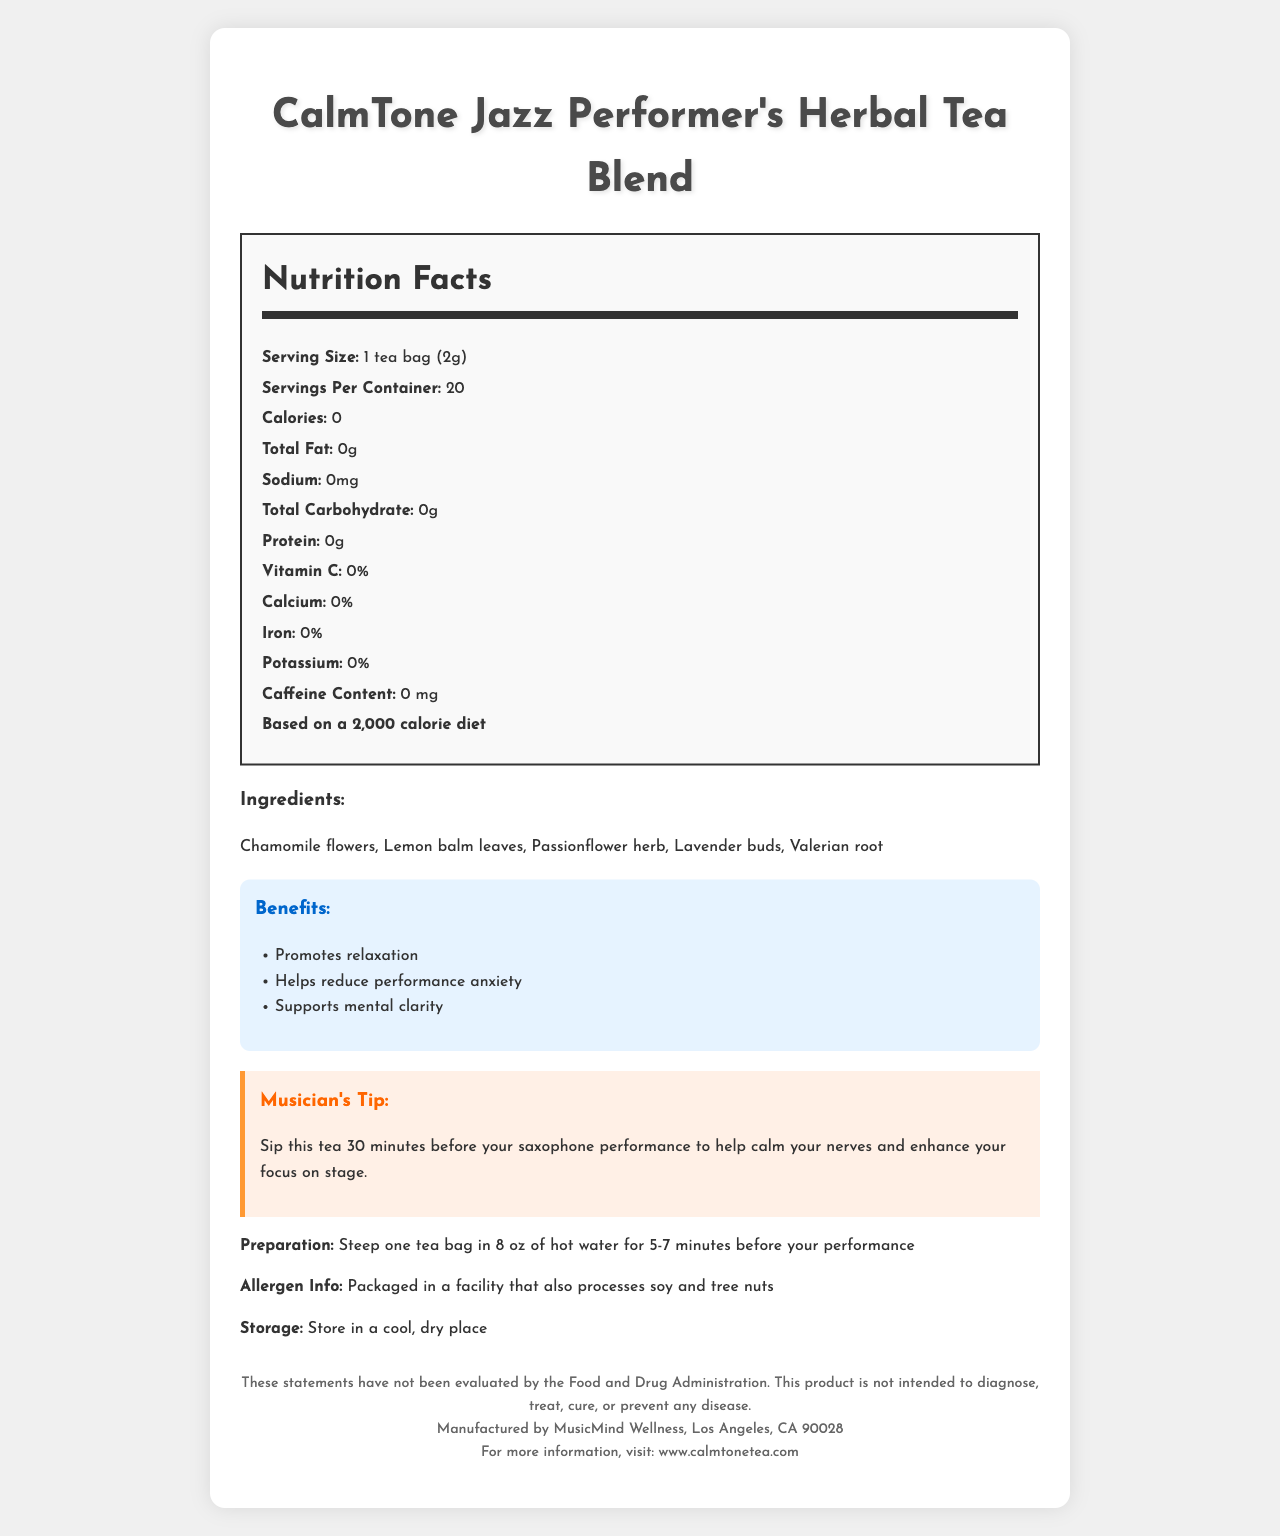what is the serving size? The document states that the serving size is 1 tea bag (2g).
Answer: 1 tea bag (2g) how many calories does each serving contain? The Nutrition Facts section mentions that each serving contains 0 calories.
Answer: 0 what are the main ingredients in the CalmTone Jazz Performer's Herbal Tea Blend? The document lists these ingredients under the Ingredients section.
Answer: Chamomile flowers, Lemon balm leaves, Passionflower herb, Lavender buds, Valerian root how much caffeine is in the CalmTone tea blend? The Nutrition Facts label indicates that the caffeine content is 0 mg.
Answer: 0 mg how many servings are there per container? The document specifies that there are 20 servings per container.
Answer: 20 which of these benefits is NOT listed for the CalmTone tea blend? A. Promotes relaxation B. Reduces performance anxiety C. Aids digestion D. Supports mental clarity The Benefits section lists "Promotes relaxation", "Helps reduce performance anxiety", and "Supports mental clarity", but not "Aids digestion".
Answer: C. Aids digestion which mineral is present in the CalmTone tea blend? A. Calcium B. Iron C. Potassium D. None The vitamins and minerals section indicates 0% for calcium, iron, and potassium, meaning none of these minerals are present in the tea blend.
Answer: D. None is this tea blend caffeine-free? The Nutrition Facts state the caffeine content as 0 mg, confirming it is caffeine-free.
Answer: Yes does the document mention where the tea blend should be stored? The storage instructions are to store the tea in a cool, dry place.
Answer: Yes what should you do 30 minutes before your saxophone performance? The document includes a Musician's Tip suggesting to sip the tea 30 minutes before the performance.
Answer: Sip this tea to help calm your nerves and enhance your focus on stage what are the preparation instructions for the tea? The preparation instructions are clearly mentioned in the document.
Answer: Steep one tea bag in 8 oz of hot water for 5-7 minutes before your performance does the tea blend contain soy? The document notes that it is packaged in a facility that also processes soy and tree nuts, but it does not specify if soy is actually in the tea blend.
Answer: Cannot be determined what information is found in the alloys section of the document? The term "alloys" does not appear in the document, making it impossible to determine information on alloys.
Answer: Not enough information what should someone allergic to soy do? The allergen information indicates that the product is packaged in a facility that also processes soy, a possible risk for someone with a soy allergy.
Answer: They should be cautious as the product is packaged in a facility that processes soy summarize the main idea of the document. The document provides comprehensive details about the CalmTone tea blend, its nutritional content, ingredients, benefits, and usage tips for jazz performers.
Answer: The CalmTone Jazz Performer's Herbal Tea Blend is a zero-calorie, caffeine-free tea designed to promote relaxation, reduce performance anxiety, and support mental clarity. It contains natural ingredients like chamomile, lemon balm, passionflower, lavender, and valerian root. The document provides preparation instructions, allergen information, and a tip for musicians to enhance focus and calm nerves before performances. 